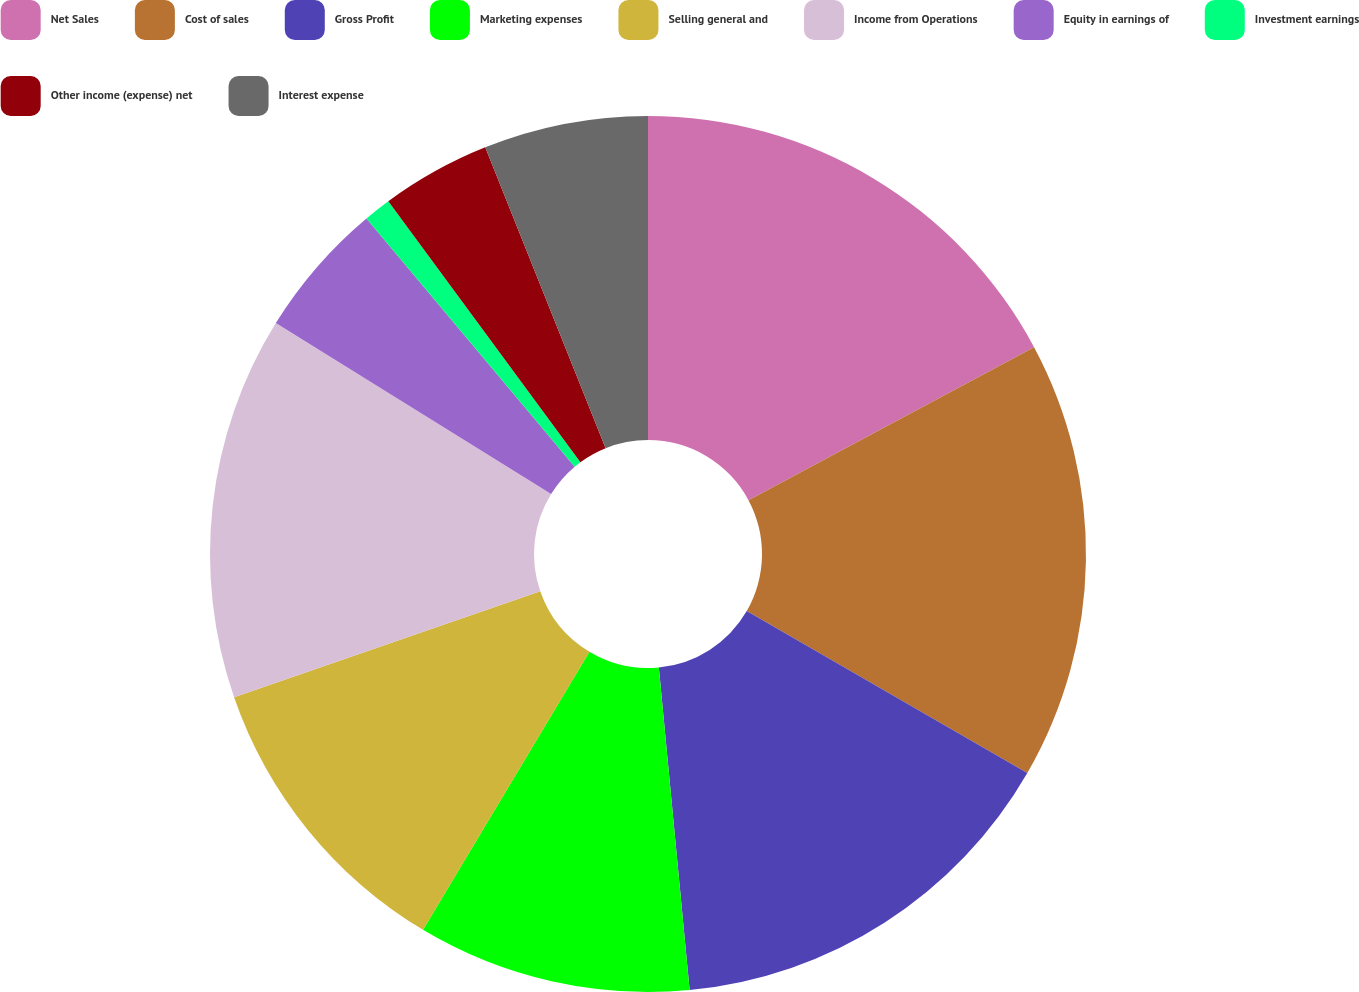<chart> <loc_0><loc_0><loc_500><loc_500><pie_chart><fcel>Net Sales<fcel>Cost of sales<fcel>Gross Profit<fcel>Marketing expenses<fcel>Selling general and<fcel>Income from Operations<fcel>Equity in earnings of<fcel>Investment earnings<fcel>Other income (expense) net<fcel>Interest expense<nl><fcel>17.17%<fcel>16.16%<fcel>15.15%<fcel>10.1%<fcel>11.11%<fcel>14.14%<fcel>5.05%<fcel>1.01%<fcel>4.04%<fcel>6.06%<nl></chart> 